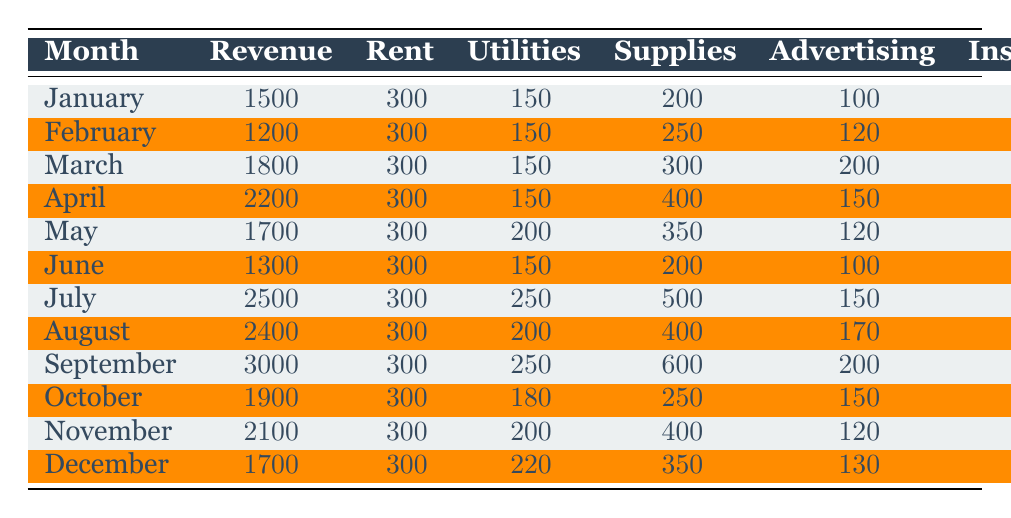What was the total revenue for the business in the month of April? In April, the revenue listed is 2200, which is directly indicated in the table. Therefore, that is the total revenue for that month.
Answer: 2200 What was the net income for the month with the highest revenue? The month with the highest revenue is September, which had a revenue of 3000. The net income for September is 1450, as indicated in the table.
Answer: 1450 What was the average net income for the first half of the year (January to June)? To calculate the average net income for January to June, we take the net incomes from the six months: 600 (Jan) + 250 (Feb) + 695 (Mar) + 1030 (Apr) + 590 (May) + 395 (Jun) = 3560. We then divide by 6 (the number of months): 3560/6 = 593.33.
Answer: 593.33 Did the business incur higher expenses in July than in February? In July, the total expenses can be calculated by summing rent, utilities, supplies, advertising, insurance, and miscellaneous costs, which gives: 300 + 250 + 500 + 150 + 80 + 100 = 1380. For February, the total expenses are: 300 + 150 + 250 + 120 + 80 + 50 = 950. Since 1380 > 950, the answer is yes.
Answer: Yes How much did the business spend on advertising in the month with the highest advertising expense? The month with the highest advertising expenses is September at 200. To find the answer, we simply refer to the corresponding advertising expense for that month: 200.
Answer: 200 What is the total amount spent on insurance throughout the year? The total insurance expense can be calculated by summing the insurance expenses for each month: 80 (Jan) + 80 (Feb) + 80 (Mar) + 80 (Apr) + 80 (May) + 80 (Jun) + 80 (Jul) + 80 (Aug) + 80 (Sep) + 80 (Oct) + 80 (Nov) + 80 (Dec) = 960.
Answer: 960 Was there ever a month where the net income fell below 300? By checking the net income for each month, January (600), February (250), March (695), April (1030), May (590), June (395), July (1020), August (1070), September (1450), October (880), November (900), and December (550). February's net income is the only one below 300, so the answer is yes.
Answer: Yes What was the percentage of revenue spent on supplies in October? The revenue in October is 1900, and the expense on supplies is 250. To find the percentage of revenue spent on supplies, we calculate (250/1900) * 100 = 13.16%.
Answer: 13.16% 